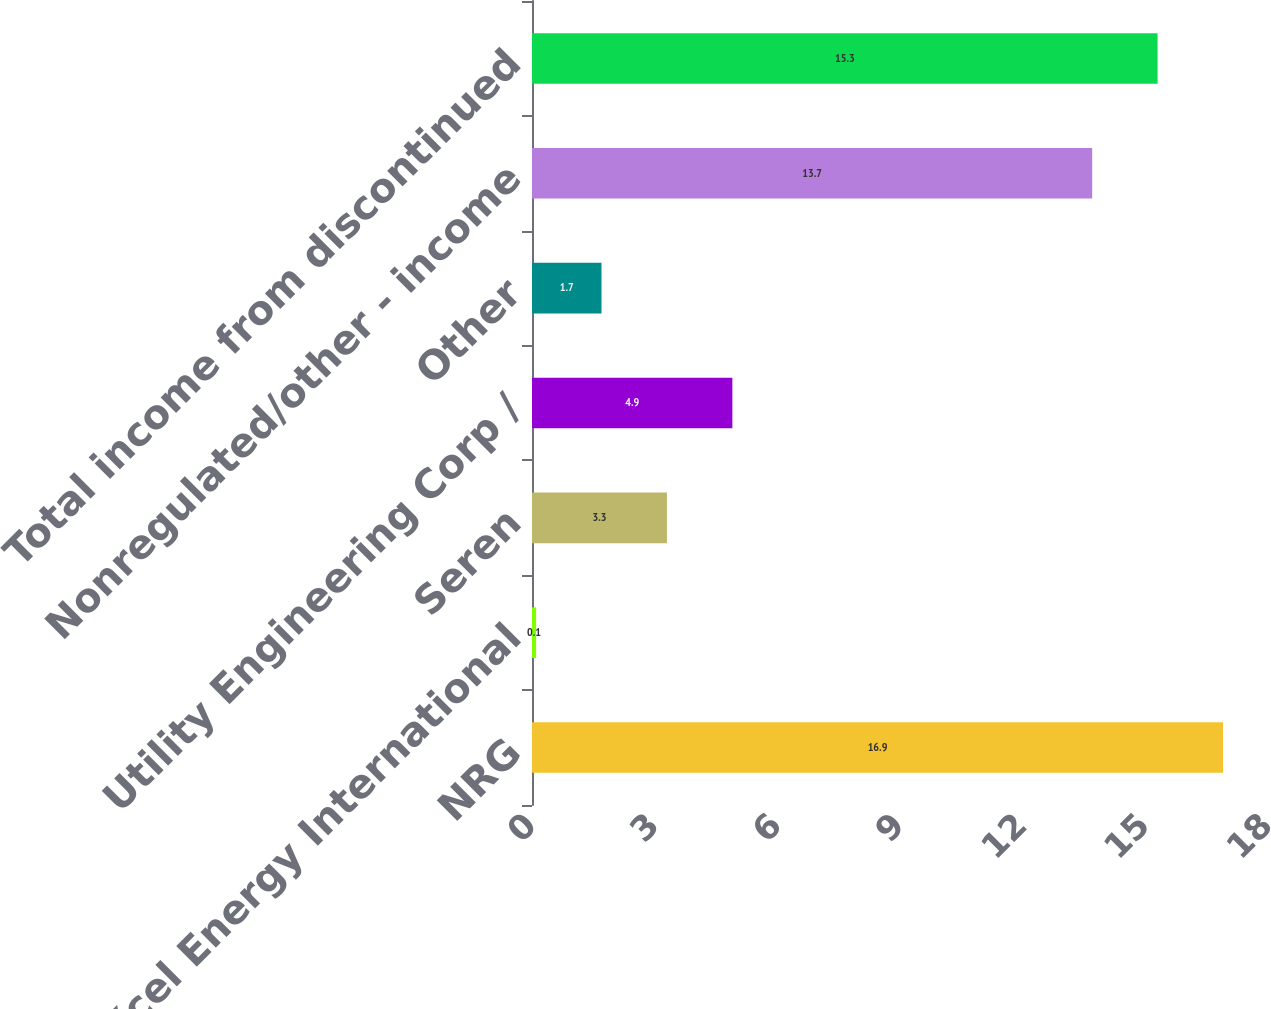Convert chart. <chart><loc_0><loc_0><loc_500><loc_500><bar_chart><fcel>NRG<fcel>Xcel Energy International<fcel>Seren<fcel>Utility Engineering Corp /<fcel>Other<fcel>Nonregulated/other - income<fcel>Total income from discontinued<nl><fcel>16.9<fcel>0.1<fcel>3.3<fcel>4.9<fcel>1.7<fcel>13.7<fcel>15.3<nl></chart> 